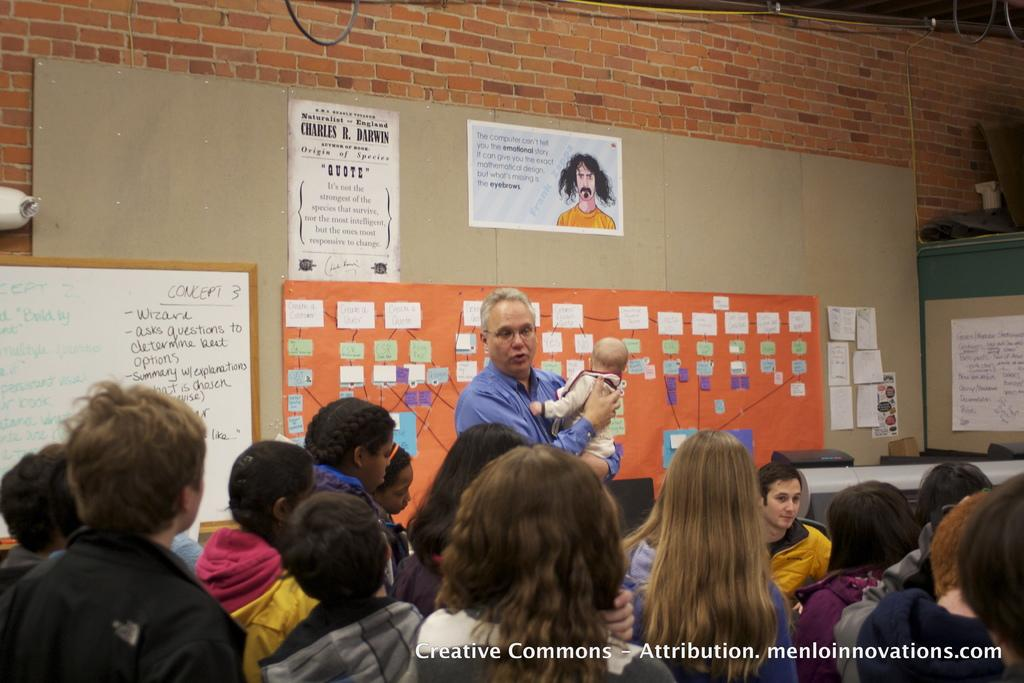How many people are in the image? There is a group of people in the image, but the exact number cannot be determined from the provided facts. What can be seen in the background of the image? In the background of the image, there is a brick wall, boards, posters, and some objects. What is present in the bottom right corner of the image? There is some text in the bottom right corner of the image. What type of business is advertised on the sign in the image? There is no sign present in the image, so it is not possible to determine what type of business might be advertised. 